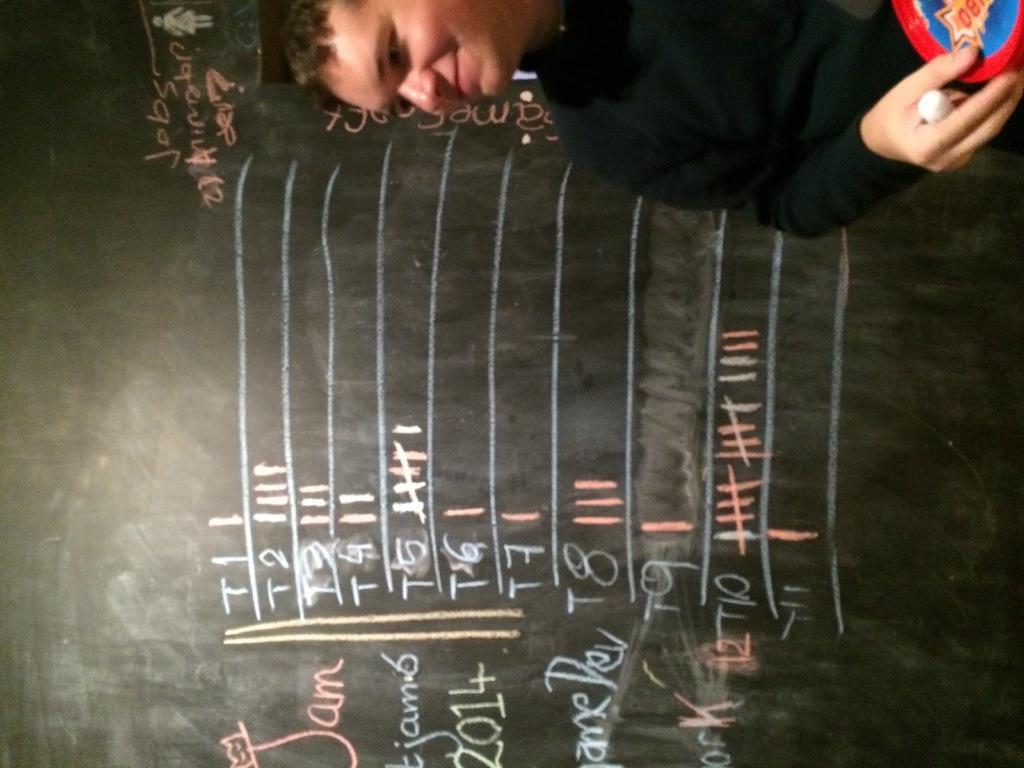Please provide a concise description of this image. In this image I see the black board on which I see words and numbers written and I see the lines and I see a man over here who is holding a white color thing and other thing in his hand and I see that he is smiling. 